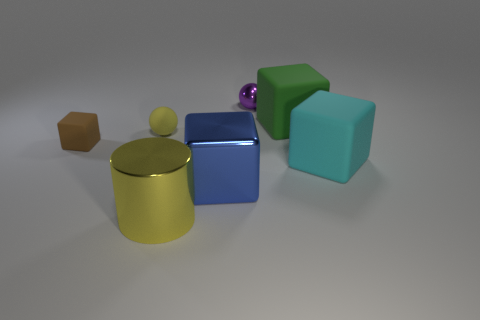Subtract 1 cubes. How many cubes are left? 3 Add 1 rubber things. How many objects exist? 8 Subtract all balls. How many objects are left? 5 Add 3 cylinders. How many cylinders are left? 4 Add 1 small yellow spheres. How many small yellow spheres exist? 2 Subtract 0 purple cylinders. How many objects are left? 7 Subtract all matte cubes. Subtract all metallic cylinders. How many objects are left? 3 